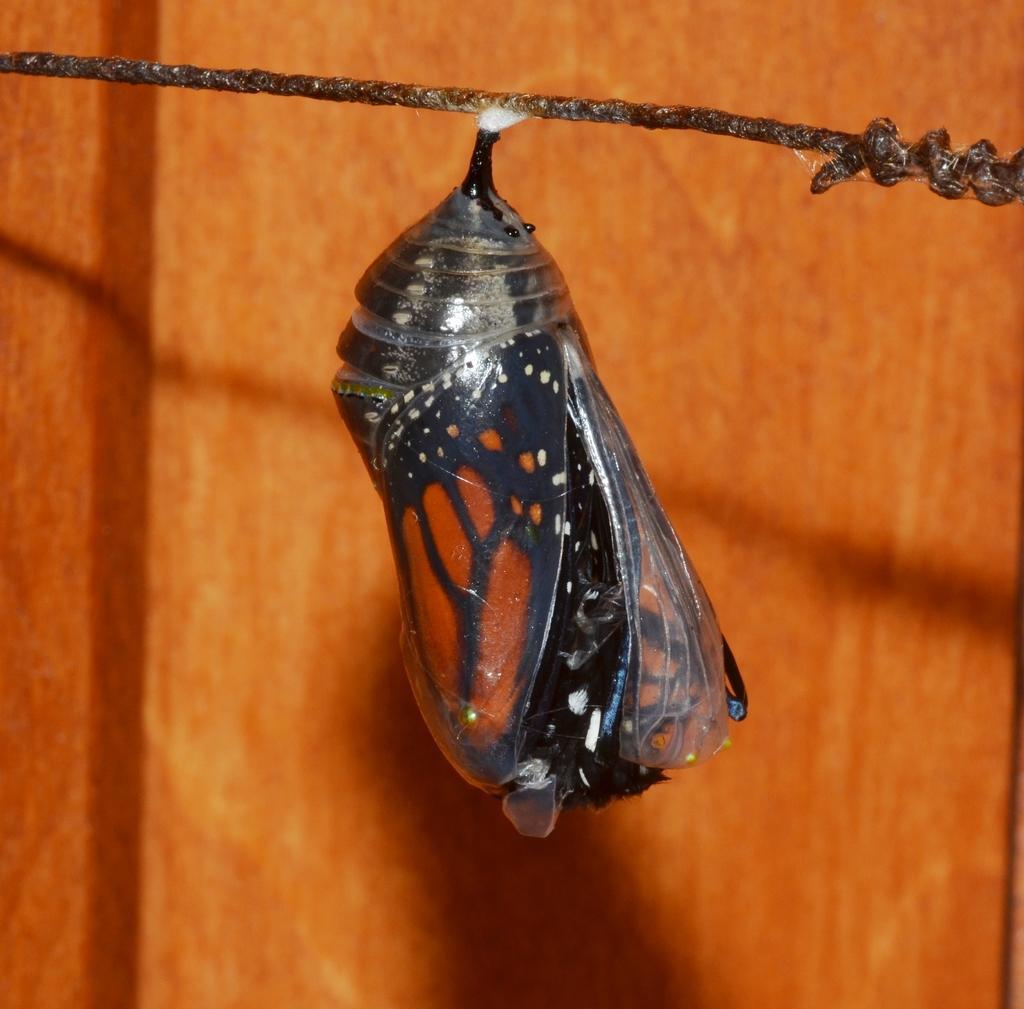How would you summarize this image in a sentence or two? In this image we can see a butterfly and a rope, in the background we can see the wall. 